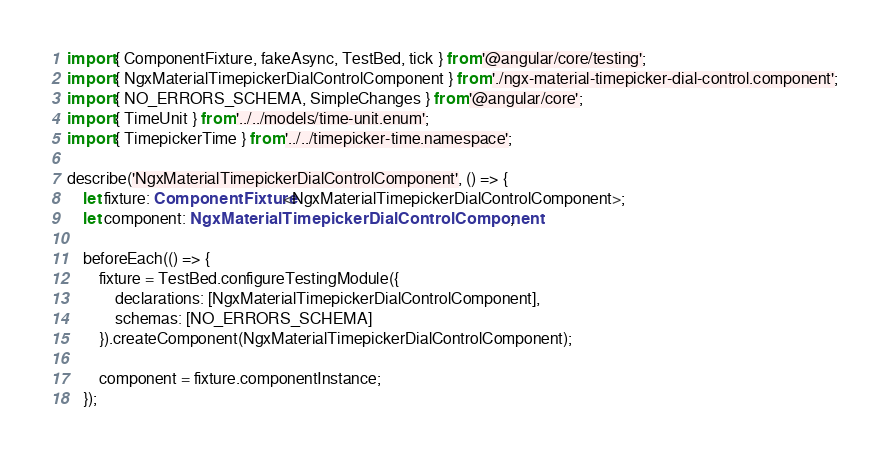Convert code to text. <code><loc_0><loc_0><loc_500><loc_500><_TypeScript_>import { ComponentFixture, fakeAsync, TestBed, tick } from '@angular/core/testing';
import { NgxMaterialTimepickerDialControlComponent } from './ngx-material-timepicker-dial-control.component';
import { NO_ERRORS_SCHEMA, SimpleChanges } from '@angular/core';
import { TimeUnit } from '../../models/time-unit.enum';
import { TimepickerTime } from '../../timepicker-time.namespace';

describe('NgxMaterialTimepickerDialControlComponent', () => {
    let fixture: ComponentFixture<NgxMaterialTimepickerDialControlComponent>;
    let component: NgxMaterialTimepickerDialControlComponent;

    beforeEach(() => {
        fixture = TestBed.configureTestingModule({
            declarations: [NgxMaterialTimepickerDialControlComponent],
            schemas: [NO_ERRORS_SCHEMA]
        }).createComponent(NgxMaterialTimepickerDialControlComponent);

        component = fixture.componentInstance;
    });
</code> 